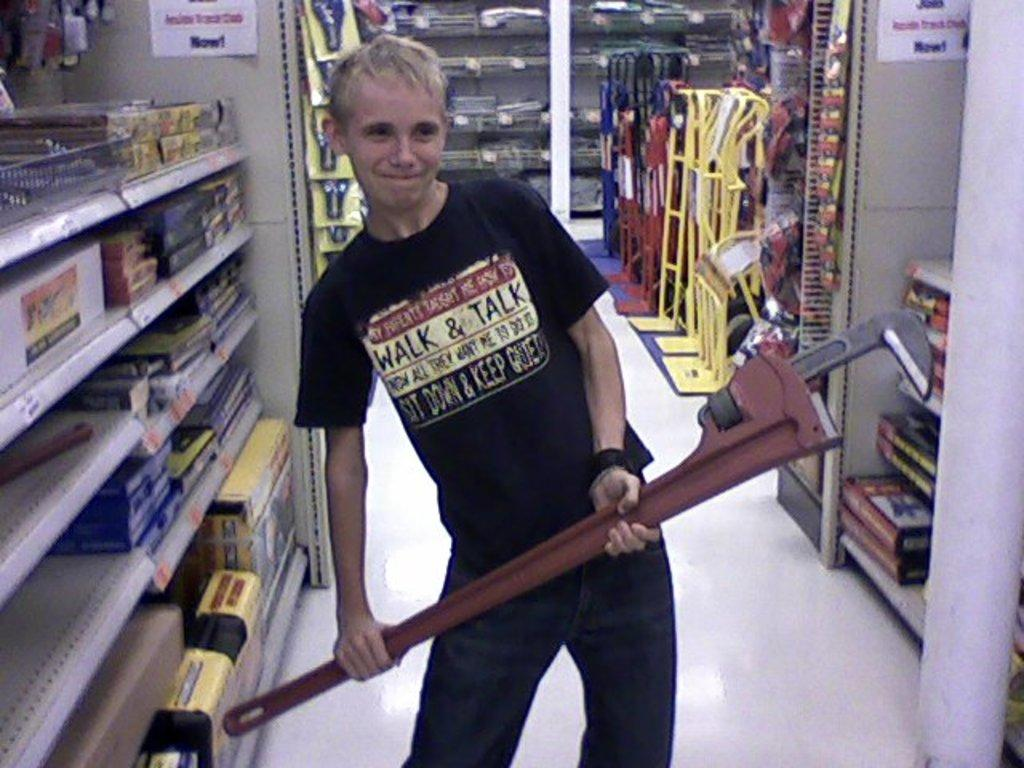<image>
Relay a brief, clear account of the picture shown. Holding a large pipe wrench is a boy wearing a shirt that says WALK & TALK. 